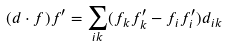<formula> <loc_0><loc_0><loc_500><loc_500>( d \cdot f ) f ^ { \prime } = \sum _ { i k } ( f _ { k } f ^ { \prime } _ { k } - f _ { i } f ^ { \prime } _ { i } ) d _ { i k }</formula> 